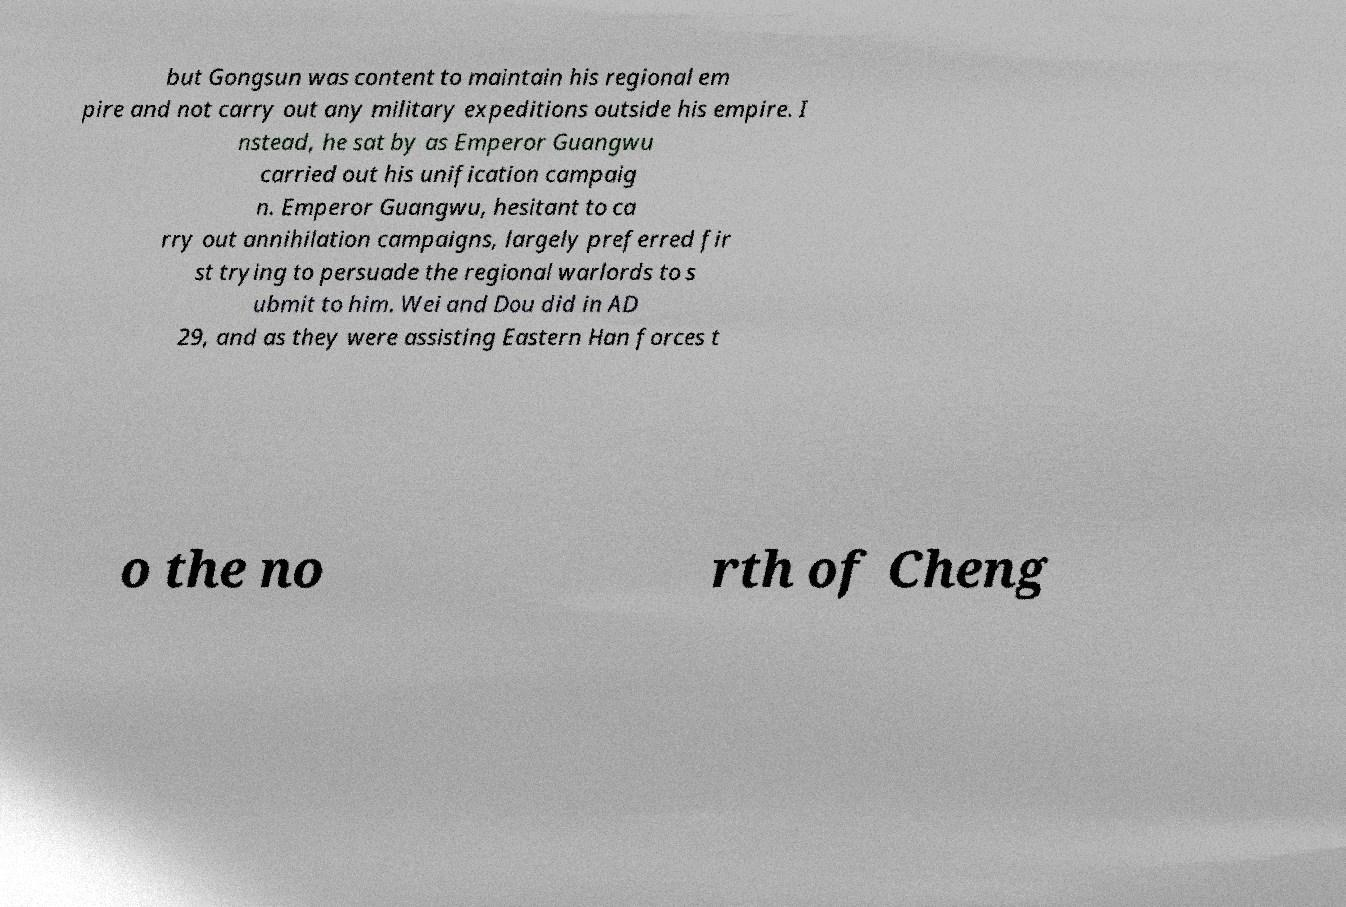There's text embedded in this image that I need extracted. Can you transcribe it verbatim? but Gongsun was content to maintain his regional em pire and not carry out any military expeditions outside his empire. I nstead, he sat by as Emperor Guangwu carried out his unification campaig n. Emperor Guangwu, hesitant to ca rry out annihilation campaigns, largely preferred fir st trying to persuade the regional warlords to s ubmit to him. Wei and Dou did in AD 29, and as they were assisting Eastern Han forces t o the no rth of Cheng 